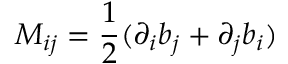<formula> <loc_0><loc_0><loc_500><loc_500>M _ { i j } = \frac { 1 } { 2 } ( \partial _ { i } b _ { j } + \partial _ { j } b _ { i } )</formula> 